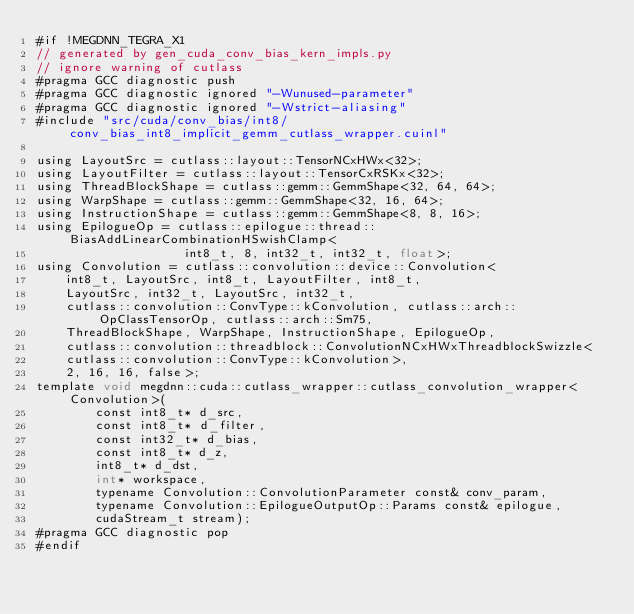<code> <loc_0><loc_0><loc_500><loc_500><_Cuda_>#if !MEGDNN_TEGRA_X1
// generated by gen_cuda_conv_bias_kern_impls.py
// ignore warning of cutlass
#pragma GCC diagnostic push
#pragma GCC diagnostic ignored "-Wunused-parameter"
#pragma GCC diagnostic ignored "-Wstrict-aliasing"
#include "src/cuda/conv_bias/int8/conv_bias_int8_implicit_gemm_cutlass_wrapper.cuinl"

using LayoutSrc = cutlass::layout::TensorNCxHWx<32>;
using LayoutFilter = cutlass::layout::TensorCxRSKx<32>;
using ThreadBlockShape = cutlass::gemm::GemmShape<32, 64, 64>;
using WarpShape = cutlass::gemm::GemmShape<32, 16, 64>;
using InstructionShape = cutlass::gemm::GemmShape<8, 8, 16>;
using EpilogueOp = cutlass::epilogue::thread::BiasAddLinearCombinationHSwishClamp<
                    int8_t, 8, int32_t, int32_t, float>;
using Convolution = cutlass::convolution::device::Convolution<
    int8_t, LayoutSrc, int8_t, LayoutFilter, int8_t, 
    LayoutSrc, int32_t, LayoutSrc, int32_t, 
    cutlass::convolution::ConvType::kConvolution, cutlass::arch::OpClassTensorOp, cutlass::arch::Sm75, 
    ThreadBlockShape, WarpShape, InstructionShape, EpilogueOp, 
    cutlass::convolution::threadblock::ConvolutionNCxHWxThreadblockSwizzle<
    cutlass::convolution::ConvType::kConvolution>, 
    2, 16, 16, false>;
template void megdnn::cuda::cutlass_wrapper::cutlass_convolution_wrapper<Convolution>(
        const int8_t* d_src, 
        const int8_t* d_filter, 
        const int32_t* d_bias, 
        const int8_t* d_z, 
        int8_t* d_dst, 
        int* workspace, 
        typename Convolution::ConvolutionParameter const& conv_param, 
        typename Convolution::EpilogueOutputOp::Params const& epilogue, 
        cudaStream_t stream);
#pragma GCC diagnostic pop
#endif
</code> 